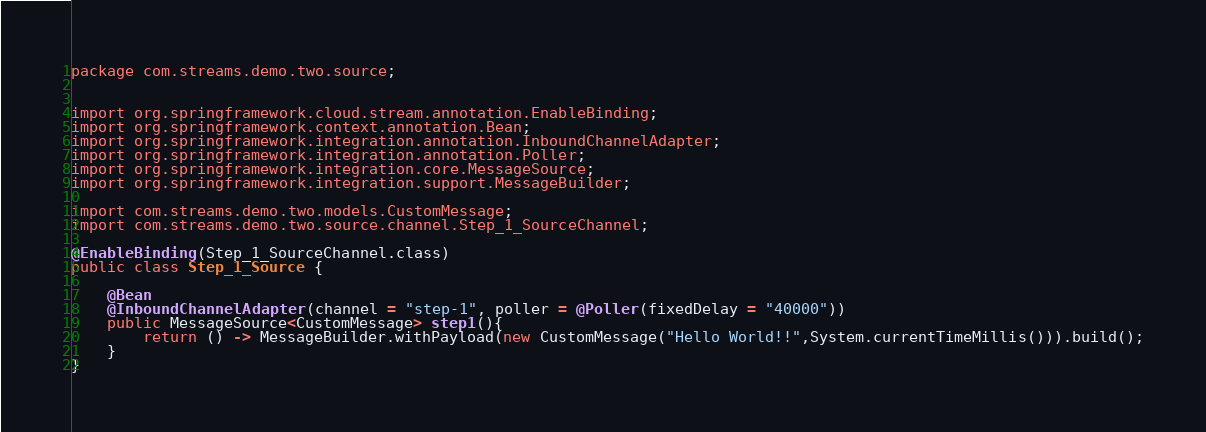Convert code to text. <code><loc_0><loc_0><loc_500><loc_500><_Java_>package com.streams.demo.two.source;


import org.springframework.cloud.stream.annotation.EnableBinding;
import org.springframework.context.annotation.Bean;
import org.springframework.integration.annotation.InboundChannelAdapter;
import org.springframework.integration.annotation.Poller;
import org.springframework.integration.core.MessageSource;
import org.springframework.integration.support.MessageBuilder;

import com.streams.demo.two.models.CustomMessage;
import com.streams.demo.two.source.channel.Step_1_SourceChannel;

@EnableBinding(Step_1_SourceChannel.class)
public class Step_1_Source {

    @Bean
    @InboundChannelAdapter(channel = "step-1", poller = @Poller(fixedDelay = "40000"))
    public MessageSource<CustomMessage> step1(){
        return () -> MessageBuilder.withPayload(new CustomMessage("Hello World!!",System.currentTimeMillis())).build();
    }
}
</code> 